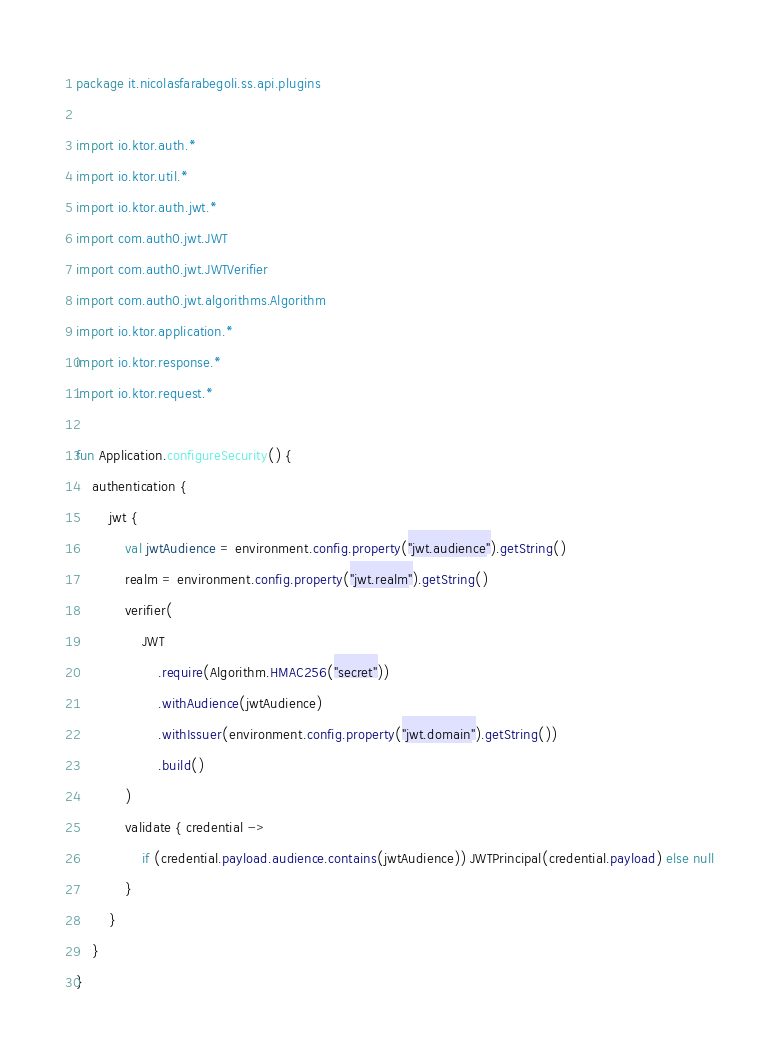Convert code to text. <code><loc_0><loc_0><loc_500><loc_500><_Kotlin_>package it.nicolasfarabegoli.ss.api.plugins

import io.ktor.auth.*
import io.ktor.util.*
import io.ktor.auth.jwt.*
import com.auth0.jwt.JWT
import com.auth0.jwt.JWTVerifier
import com.auth0.jwt.algorithms.Algorithm
import io.ktor.application.*
import io.ktor.response.*
import io.ktor.request.*

fun Application.configureSecurity() {
    authentication {
        jwt {
            val jwtAudience = environment.config.property("jwt.audience").getString()
            realm = environment.config.property("jwt.realm").getString()
            verifier(
                JWT
                    .require(Algorithm.HMAC256("secret"))
                    .withAudience(jwtAudience)
                    .withIssuer(environment.config.property("jwt.domain").getString())
                    .build()
            )
            validate { credential ->
                if (credential.payload.audience.contains(jwtAudience)) JWTPrincipal(credential.payload) else null
            }
        }
    }
}
</code> 